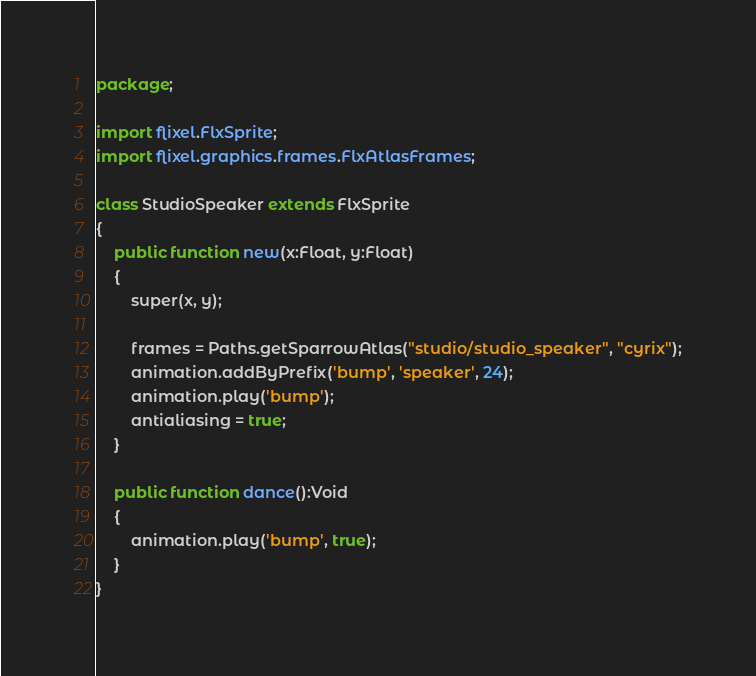<code> <loc_0><loc_0><loc_500><loc_500><_Haxe_>package;

import flixel.FlxSprite;
import flixel.graphics.frames.FlxAtlasFrames;

class StudioSpeaker extends FlxSprite
{
	public function new(x:Float, y:Float)
	{
		super(x, y);

		frames = Paths.getSparrowAtlas("studio/studio_speaker", "cyrix");
		animation.addByPrefix('bump', 'speaker', 24);
		animation.play('bump');
		antialiasing = true;
	}

	public function dance():Void
	{
		animation.play('bump', true);
	}
}</code> 